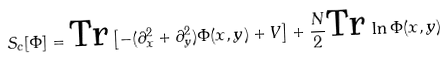Convert formula to latex. <formula><loc_0><loc_0><loc_500><loc_500>S _ { c } [ \Phi ] = \text {Tr} \left [ - ( \partial _ { x } ^ { 2 } + \partial _ { y } ^ { 2 } ) \Phi ( x , y ) + V \right ] + \frac { N } { 2 } \text {Tr} \, \ln \Phi ( x , y )</formula> 